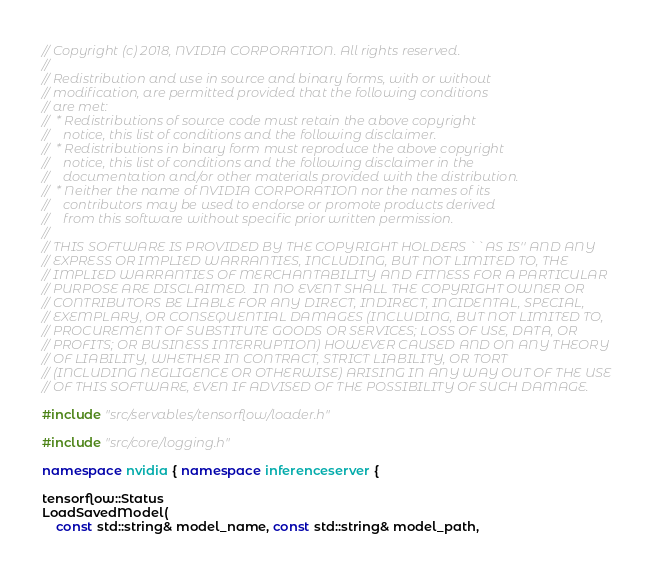Convert code to text. <code><loc_0><loc_0><loc_500><loc_500><_C++_>// Copyright (c) 2018, NVIDIA CORPORATION. All rights reserved.
//
// Redistribution and use in source and binary forms, with or without
// modification, are permitted provided that the following conditions
// are met:
//  * Redistributions of source code must retain the above copyright
//    notice, this list of conditions and the following disclaimer.
//  * Redistributions in binary form must reproduce the above copyright
//    notice, this list of conditions and the following disclaimer in the
//    documentation and/or other materials provided with the distribution.
//  * Neither the name of NVIDIA CORPORATION nor the names of its
//    contributors may be used to endorse or promote products derived
//    from this software without specific prior written permission.
//
// THIS SOFTWARE IS PROVIDED BY THE COPYRIGHT HOLDERS ``AS IS'' AND ANY
// EXPRESS OR IMPLIED WARRANTIES, INCLUDING, BUT NOT LIMITED TO, THE
// IMPLIED WARRANTIES OF MERCHANTABILITY AND FITNESS FOR A PARTICULAR
// PURPOSE ARE DISCLAIMED.  IN NO EVENT SHALL THE COPYRIGHT OWNER OR
// CONTRIBUTORS BE LIABLE FOR ANY DIRECT, INDIRECT, INCIDENTAL, SPECIAL,
// EXEMPLARY, OR CONSEQUENTIAL DAMAGES (INCLUDING, BUT NOT LIMITED TO,
// PROCUREMENT OF SUBSTITUTE GOODS OR SERVICES; LOSS OF USE, DATA, OR
// PROFITS; OR BUSINESS INTERRUPTION) HOWEVER CAUSED AND ON ANY THEORY
// OF LIABILITY, WHETHER IN CONTRACT, STRICT LIABILITY, OR TORT
// (INCLUDING NEGLIGENCE OR OTHERWISE) ARISING IN ANY WAY OUT OF THE USE
// OF THIS SOFTWARE, EVEN IF ADVISED OF THE POSSIBILITY OF SUCH DAMAGE.

#include "src/servables/tensorflow/loader.h"

#include "src/core/logging.h"

namespace nvidia { namespace inferenceserver {

tensorflow::Status
LoadSavedModel(
    const std::string& model_name, const std::string& model_path,</code> 